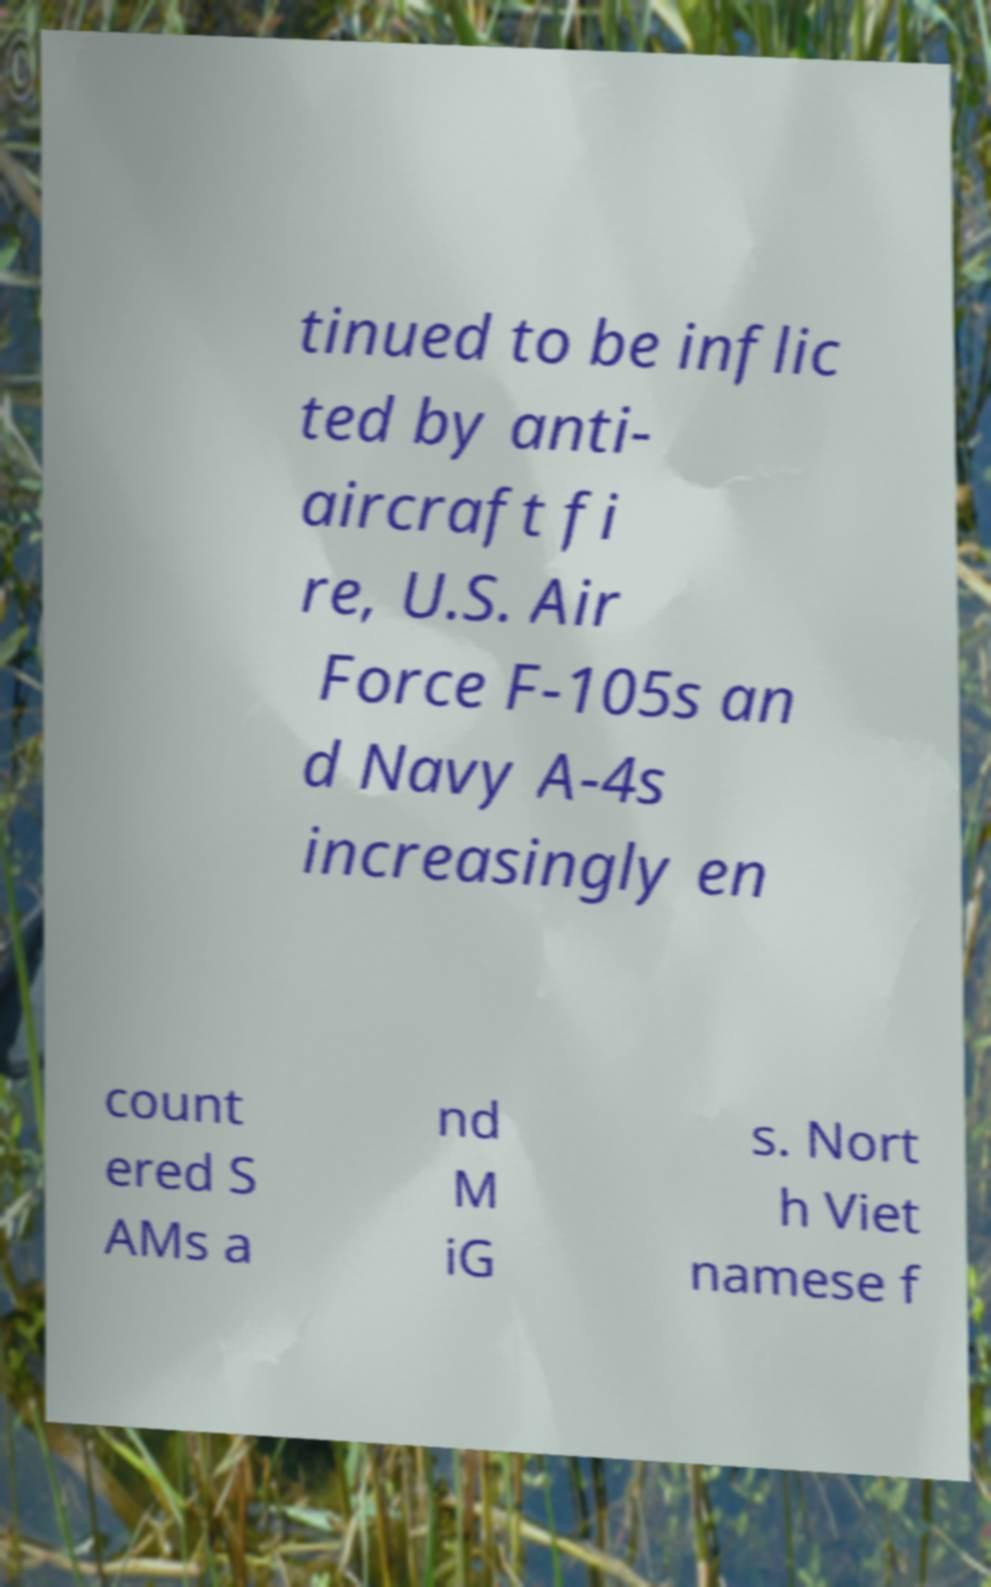Please read and relay the text visible in this image. What does it say? tinued to be inflic ted by anti- aircraft fi re, U.S. Air Force F-105s an d Navy A-4s increasingly en count ered S AMs a nd M iG s. Nort h Viet namese f 